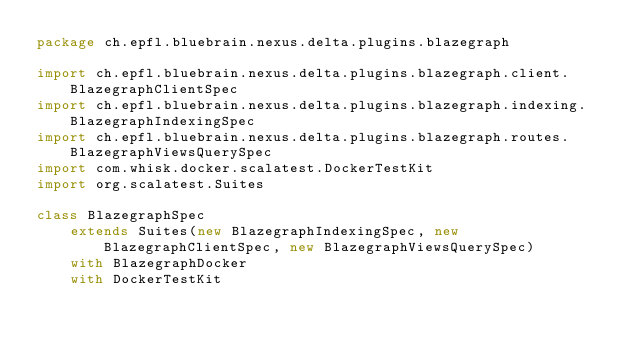Convert code to text. <code><loc_0><loc_0><loc_500><loc_500><_Scala_>package ch.epfl.bluebrain.nexus.delta.plugins.blazegraph

import ch.epfl.bluebrain.nexus.delta.plugins.blazegraph.client.BlazegraphClientSpec
import ch.epfl.bluebrain.nexus.delta.plugins.blazegraph.indexing.BlazegraphIndexingSpec
import ch.epfl.bluebrain.nexus.delta.plugins.blazegraph.routes.BlazegraphViewsQuerySpec
import com.whisk.docker.scalatest.DockerTestKit
import org.scalatest.Suites

class BlazegraphSpec
    extends Suites(new BlazegraphIndexingSpec, new BlazegraphClientSpec, new BlazegraphViewsQuerySpec)
    with BlazegraphDocker
    with DockerTestKit
</code> 